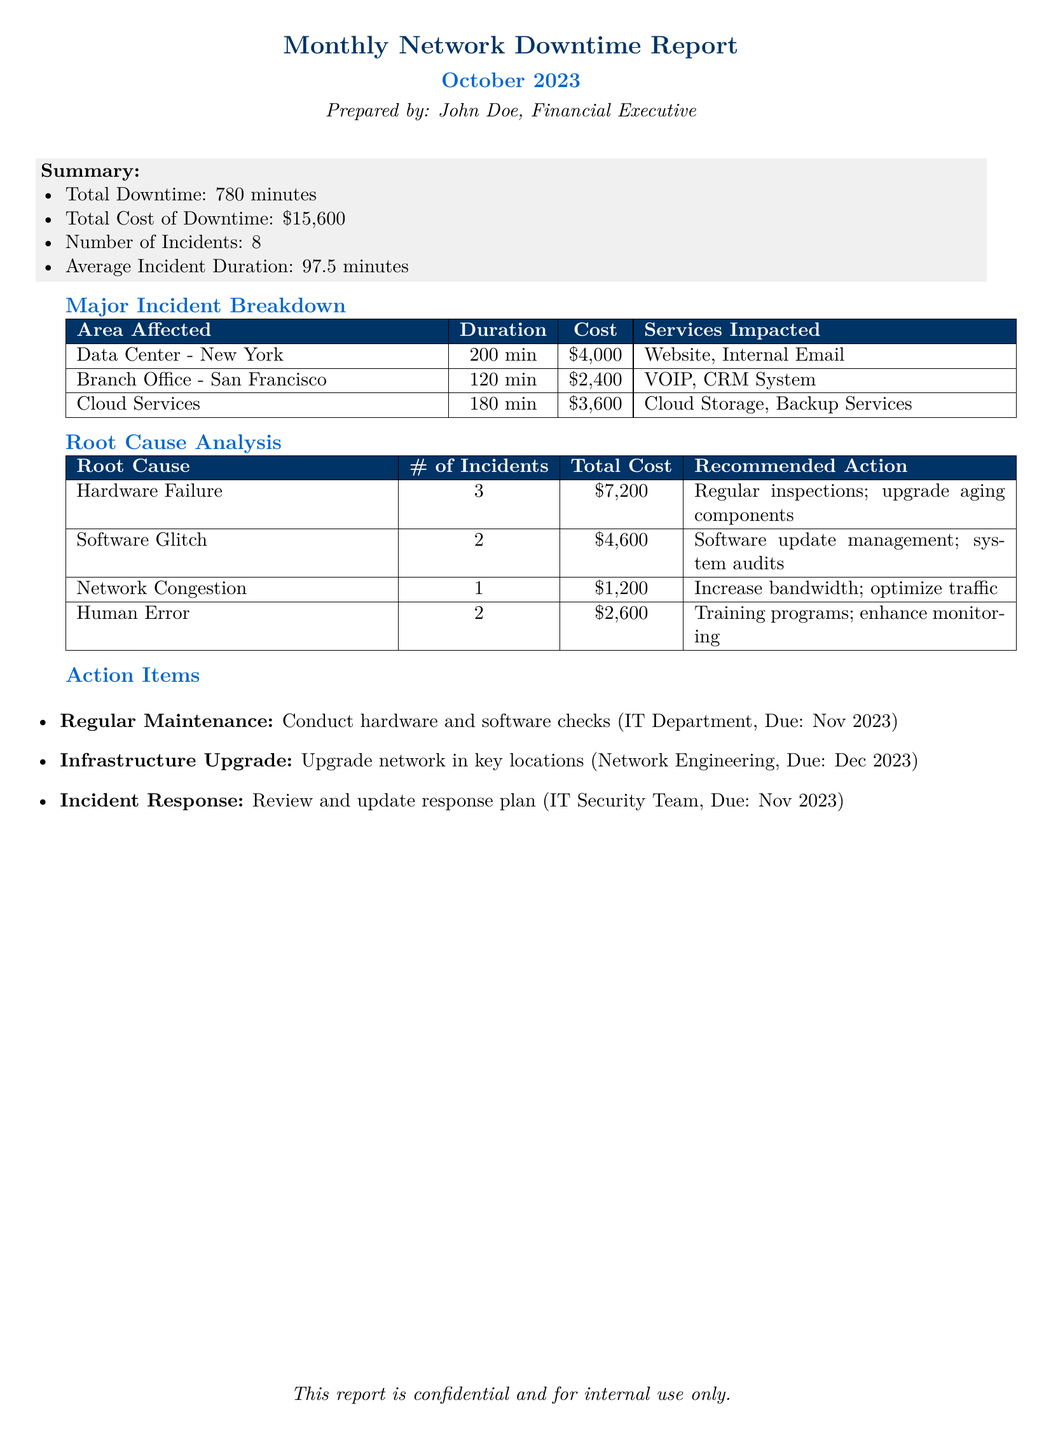What is the total downtime reported? The total downtime is listed in the summary section of the document, which states it is 780 minutes.
Answer: 780 minutes What is the total cost of downtime? The total cost of downtime is provided in the summary section and is stated as $15,600.
Answer: $15,600 What was the average incident duration? The average incident duration can be found in the summary section, which specifies it as 97.5 minutes.
Answer: 97.5 minutes How many incidents were reported in total? The total number of incidents is mentioned in the summary, indicating there were 8 incidents.
Answer: 8 What is the recommended action for hardware failure? The recommended action for hardware failure can be found in the root cause analysis section and is stated as regular inspections and upgrading aging components.
Answer: Regular inspections; upgrade aging components Which area had the highest cost associated with downtime? The area with the highest cost can be found in the major incident breakdown, which shows Data Center - New York with a cost of $4,000.
Answer: Data Center - New York How many incidents were caused by human error? The number of incidents caused by human error is stated in the root cause analysis section, listing 2 incidents.
Answer: 2 What are the due dates for the regular maintenance action item? The due date for the regular maintenance action item is mentioned in the action items section, which states it is due in November 2023.
Answer: November 2023 What services were impacted in the Cloud Services incident? The services impacted are listed in the major incident breakdown and includes Cloud Storage and Backup Services.
Answer: Cloud Storage, Backup Services 